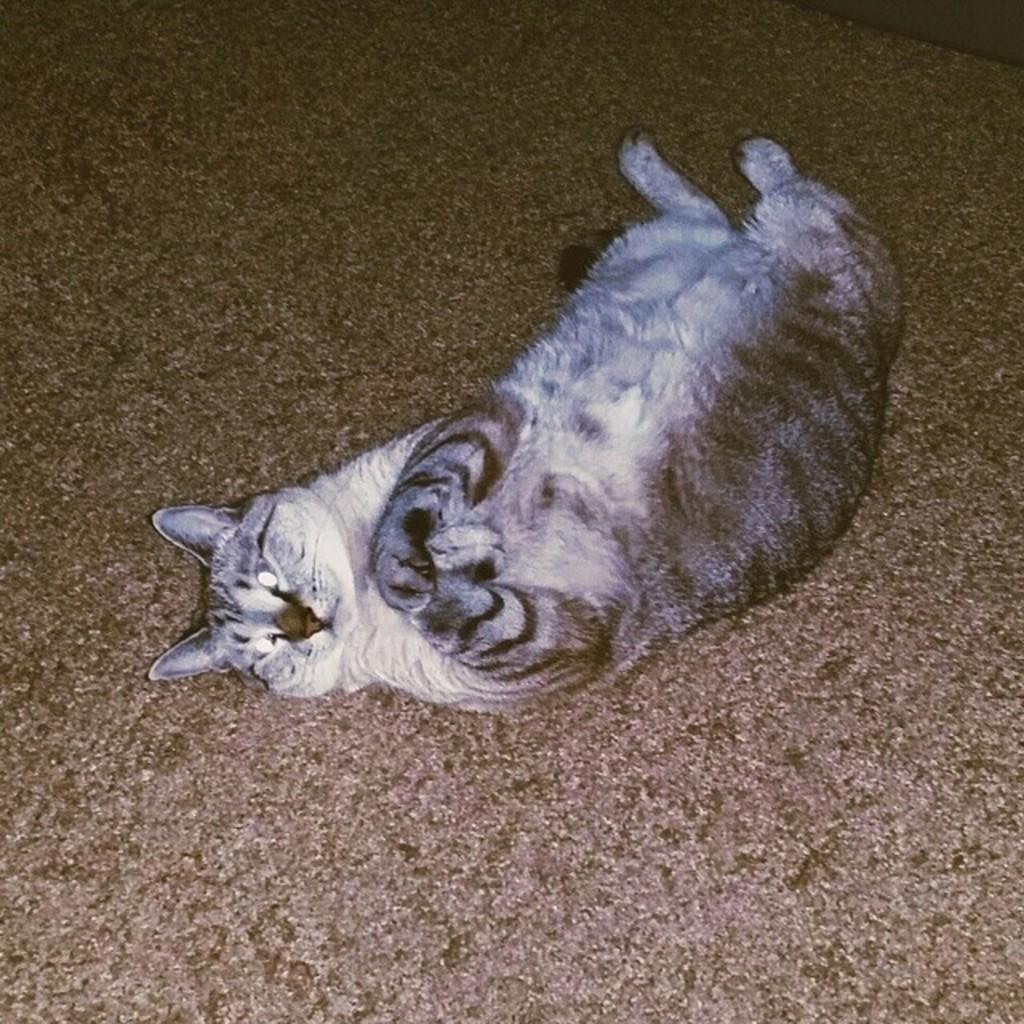What type of animal is in the picture? There is a cat in the picture. What colors can be seen on the cat? The cat has grey and white colors. What position is the cat in? The cat is lying on the floor. What is the color of the flooring in the picture? The flooring has a brown color. What type of cave can be seen in the background of the picture? There is no cave present in the image; it features a cat lying on a brown-colored floor. 